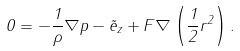<formula> <loc_0><loc_0><loc_500><loc_500>0 = - \frac { 1 } { \rho } \nabla p - \vec { e } _ { z } + F \nabla \left ( \frac { 1 } { 2 } r ^ { 2 } \right ) .</formula> 